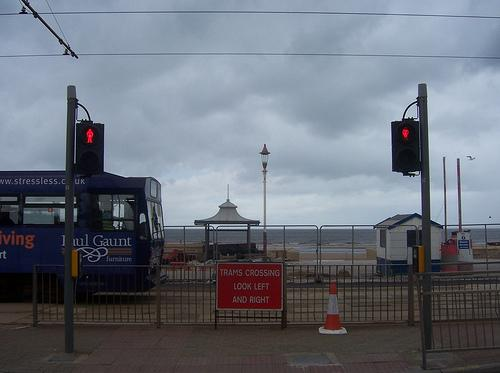Seeing dark clouds in the sky will remind you to bring what accessory that would be helpful if it starts to rain? umbrella 